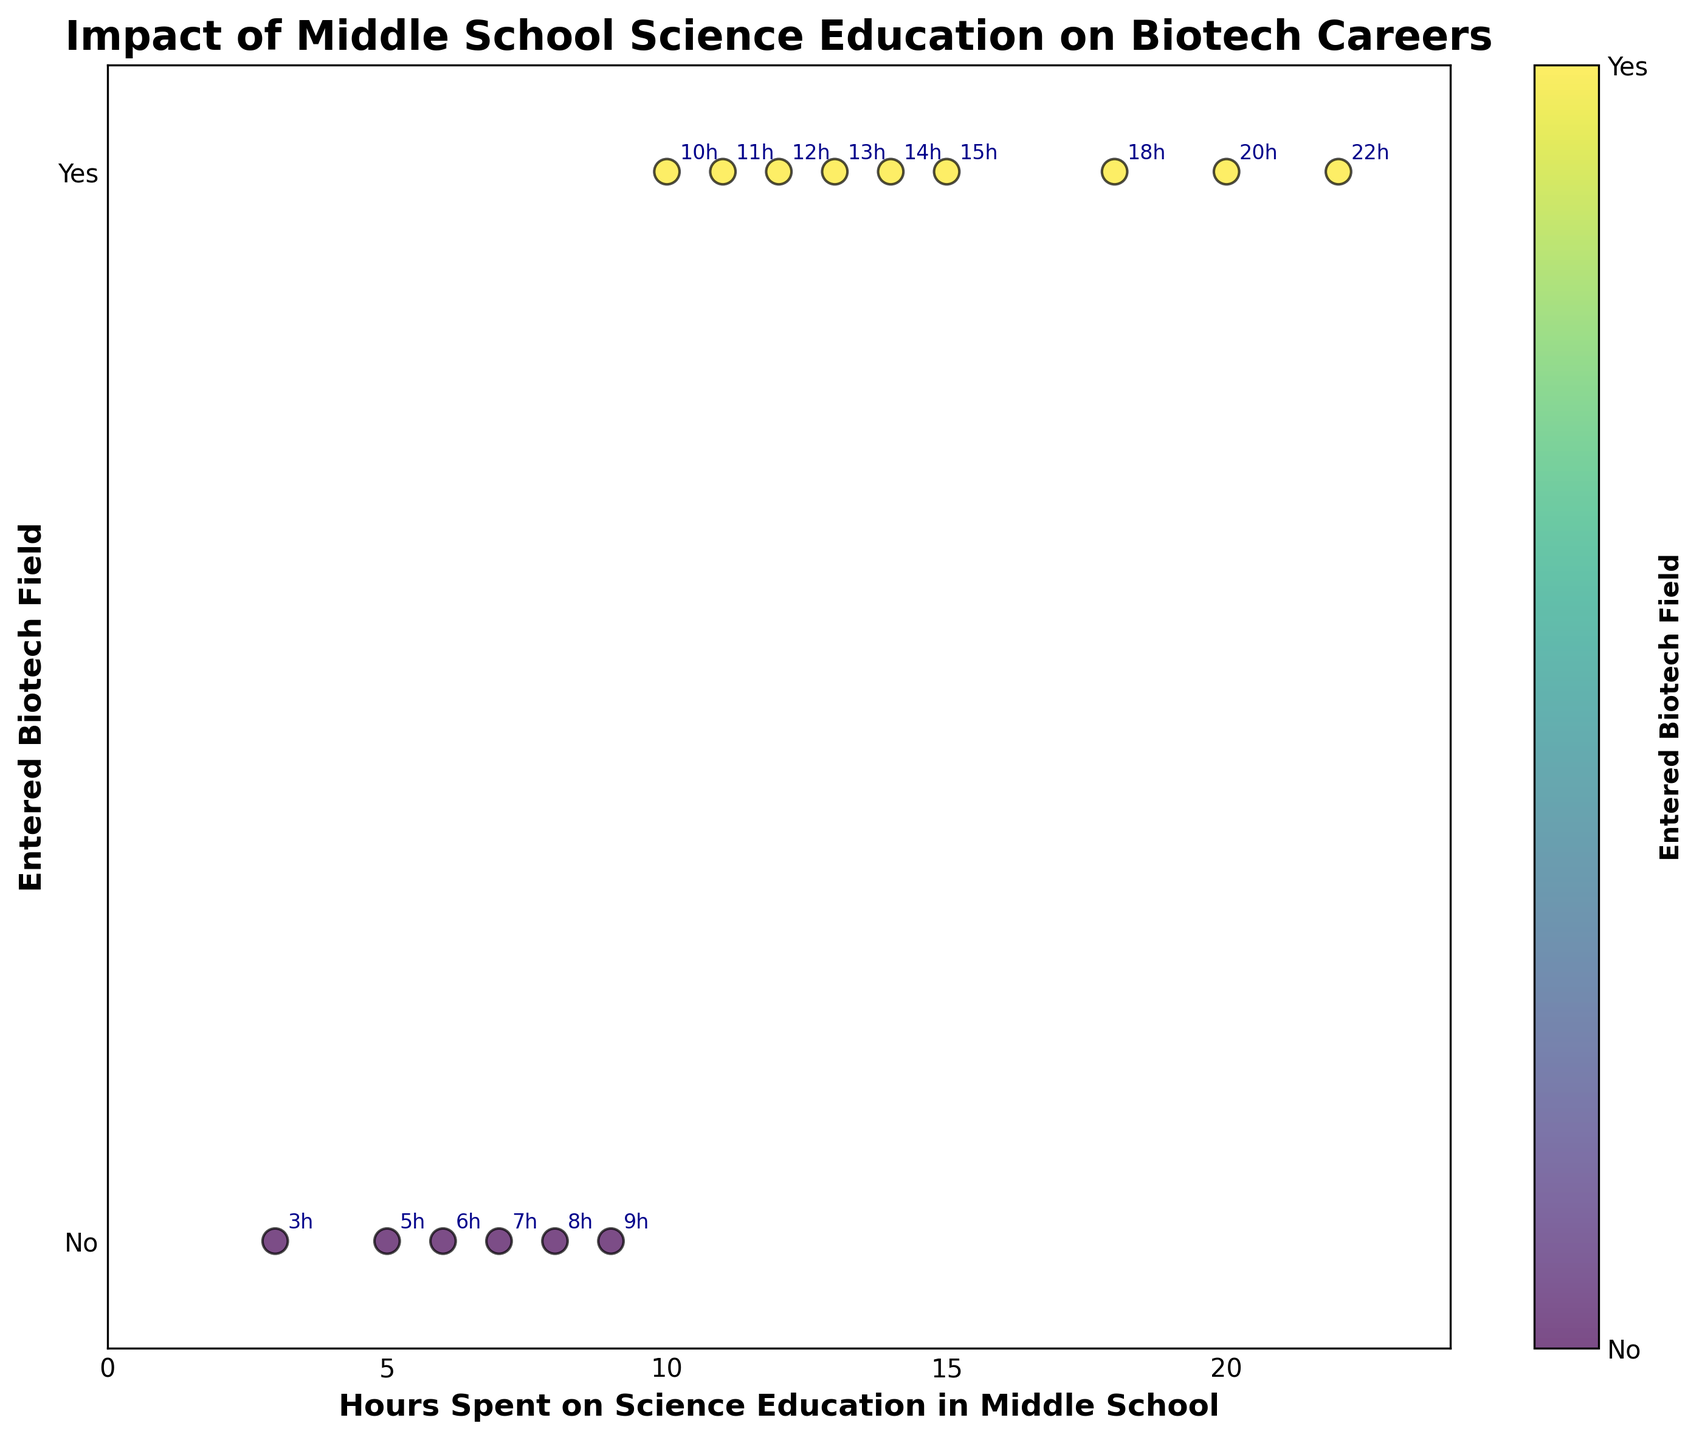How many data points are there in the scatter plot? By visually counting the scatter points displayed on the plot, we determine the number of data points.
Answer: 15 What is the title of the scatter plot? The title is displayed at the top of the scatter plot and provides a concise description of what the plot represents.
Answer: Impact of Middle School Science Education on Biotech Careers What does the y-axis represent? The y-axis label indicates whether an individual entered the biotechnology field or not.
Answer: Entered Biotech Field What is the range of hours spent on science education depicted on the x-axis? The x-axis range is derived from the minimum to the maximum values of hours shown in the scatter plot.
Answer: 0 to 24 hours How many people spent more than 10 hours on science education and did not enter the biotech field? By identifying data points where the x-value (hours) is greater than 10 and the y-value (entered biotech field) is 0, we count the relevant points.
Answer: 0 How many people entered the biotechnology field? Count the number of data points where the y-value (entered biotech field) is 1.
Answer: 9 What is the average number of hours spent on science education for those who entered the biotech field? Sum the hours spent on science education for individuals who entered the biotech field and divide by the number of such individuals. \( (10 + 12 + 15 + 14 + 20 + 18 + 13 + 11 + 22) / 9 \approx 15.0 \)
Answer: 15.0 Is there a visible trend between hours spent on science education and entering the biotech field? By observing the plotted points, we look for any pattern or trend indicating a relationship between the variables. There seems to be a visible trend where individuals who spent more hours on science education are more likely to enter the biotech field.
Answer: Yes What is the highest number of hours spent on science education by someone who did not enter the biotech field? Identify the data point with the highest x-value where the y-value is 0.
Answer: 9 For those who did not enter the biotech field, what is the range of hours spent on science education? Find the minimum and maximum hours spent on science education among data points where the y-value is 0. The minimum is 3 and the maximum is 9.
Answer: 3 to 9 